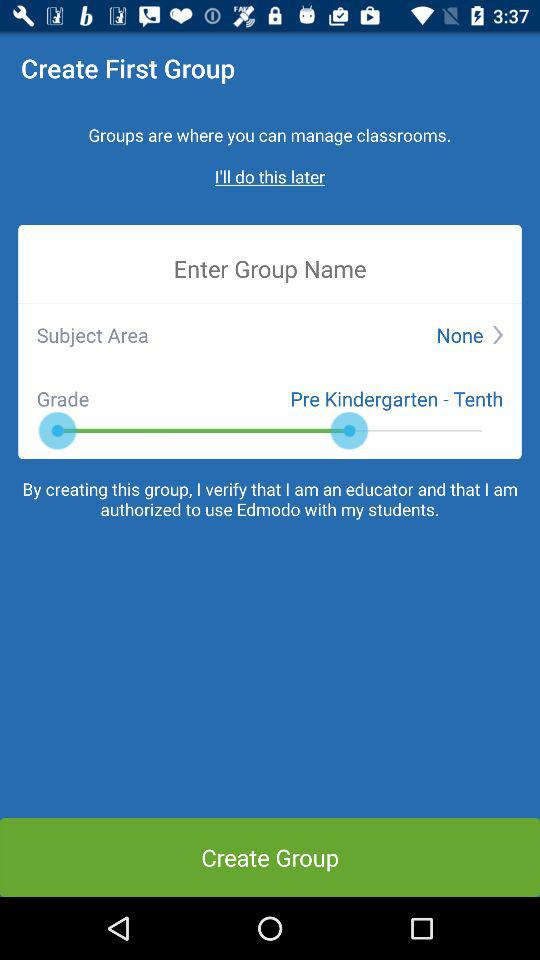What is "Subject Area"?
Answer the question using a single word or phrase. It is "None". 